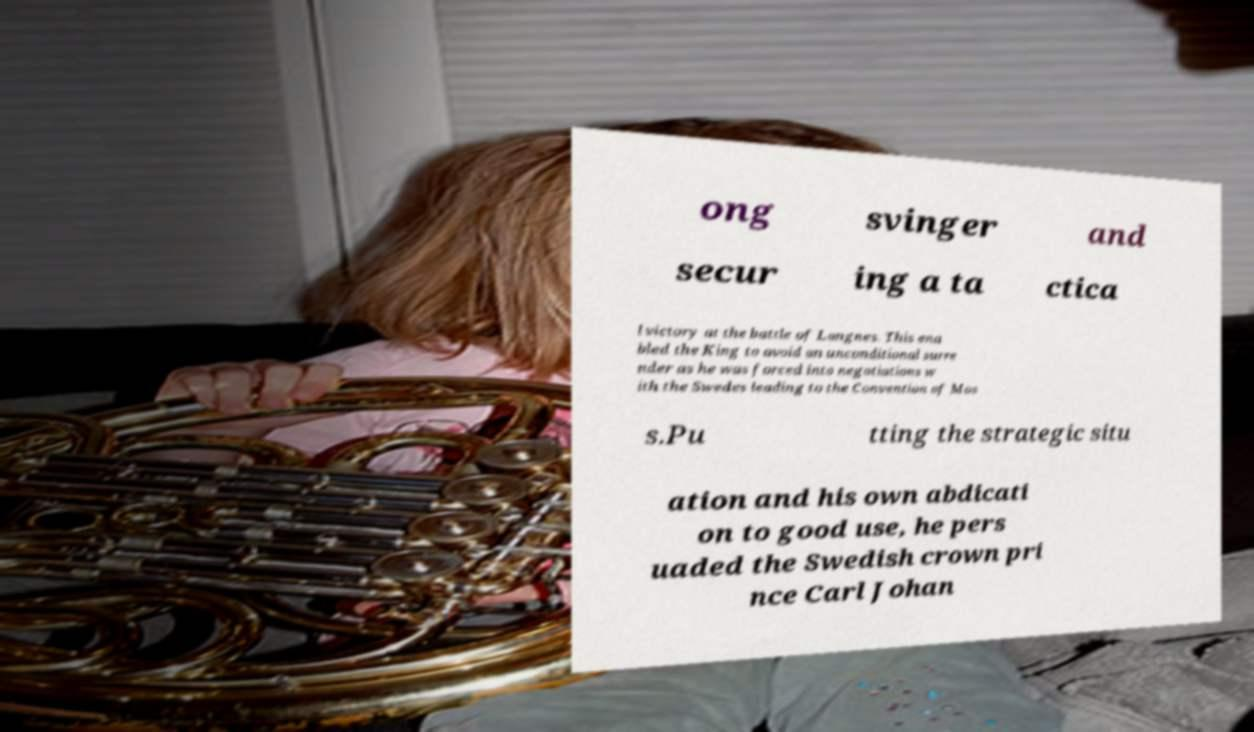Please read and relay the text visible in this image. What does it say? ong svinger and secur ing a ta ctica l victory at the battle of Langnes. This ena bled the King to avoid an unconditional surre nder as he was forced into negotiations w ith the Swedes leading to the Convention of Mos s.Pu tting the strategic situ ation and his own abdicati on to good use, he pers uaded the Swedish crown pri nce Carl Johan 